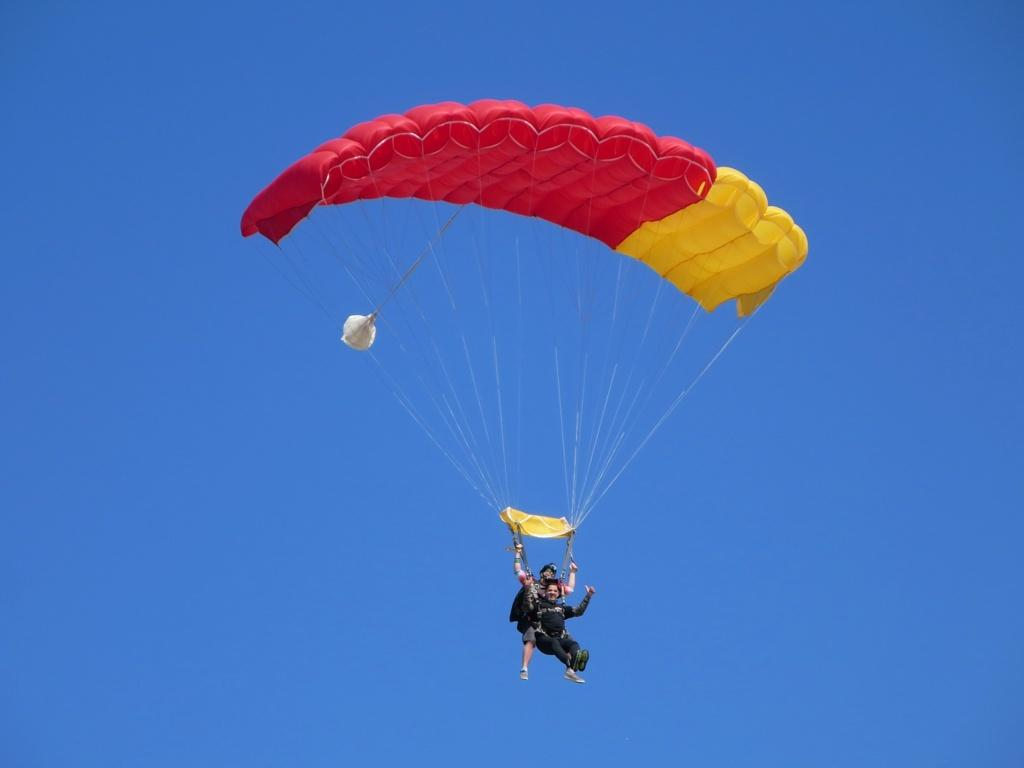How many people are in the image? There are two persons in the image. What are the persons doing in the image? The persons are flying in the air. How are they able to fly in the air? They are using a parachute. What colors are the parachute in the image? The parachute is in red and yellow colors. What can be seen in the background of the image? The sky is visible in the background of the image. Are there any fairies visible in the image? There are no fairies present in the image; it features two persons flying with a parachute. 